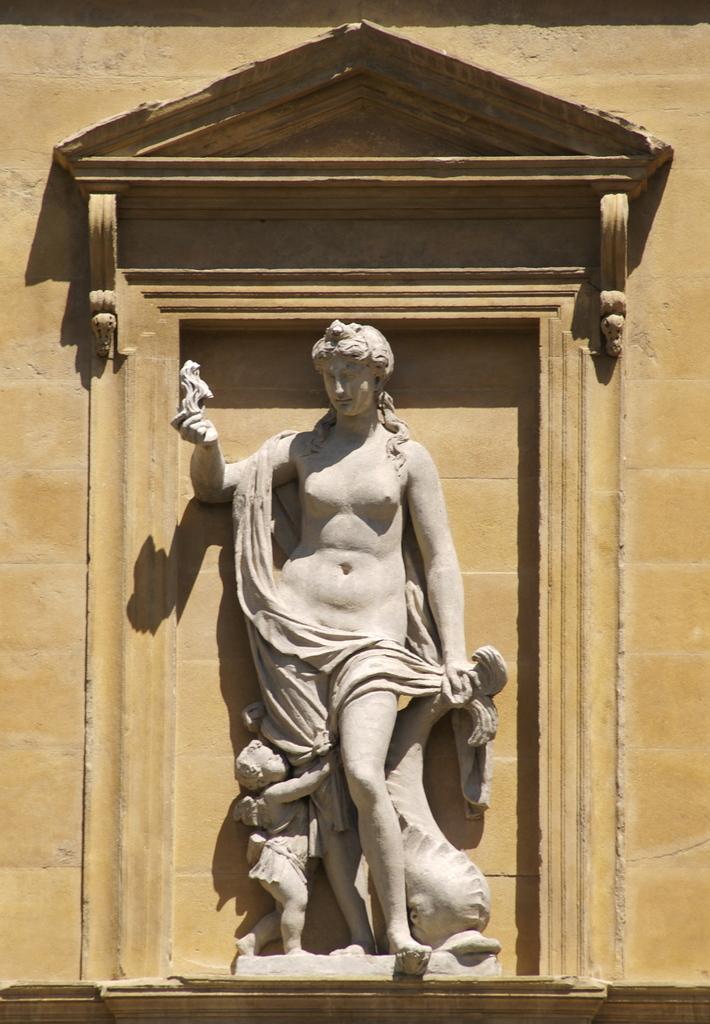Could you give a brief overview of what you see in this image? This picture shows a statue of woman and child and we see a wall. 